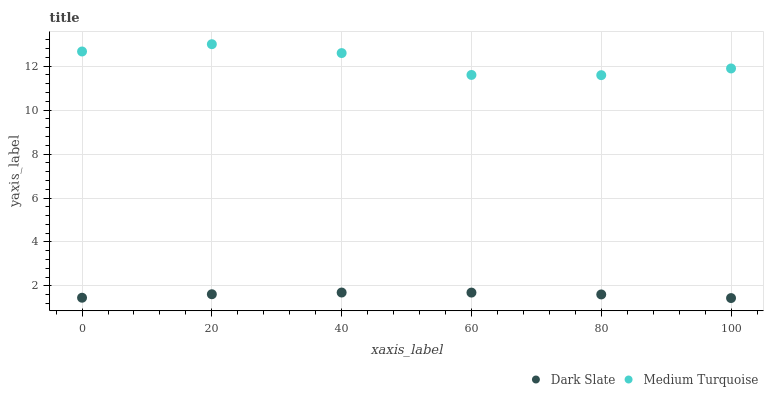Does Dark Slate have the minimum area under the curve?
Answer yes or no. Yes. Does Medium Turquoise have the maximum area under the curve?
Answer yes or no. Yes. Does Medium Turquoise have the minimum area under the curve?
Answer yes or no. No. Is Dark Slate the smoothest?
Answer yes or no. Yes. Is Medium Turquoise the roughest?
Answer yes or no. Yes. Is Medium Turquoise the smoothest?
Answer yes or no. No. Does Dark Slate have the lowest value?
Answer yes or no. Yes. Does Medium Turquoise have the lowest value?
Answer yes or no. No. Does Medium Turquoise have the highest value?
Answer yes or no. Yes. Is Dark Slate less than Medium Turquoise?
Answer yes or no. Yes. Is Medium Turquoise greater than Dark Slate?
Answer yes or no. Yes. Does Dark Slate intersect Medium Turquoise?
Answer yes or no. No. 